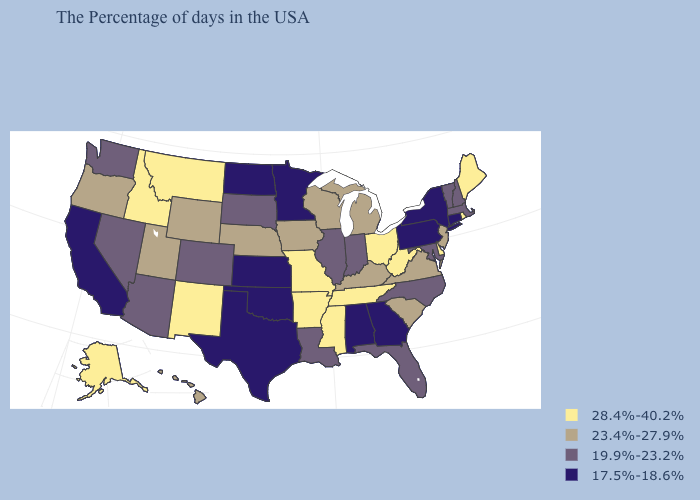Does the first symbol in the legend represent the smallest category?
Keep it brief. No. How many symbols are there in the legend?
Short answer required. 4. What is the value of Arkansas?
Quick response, please. 28.4%-40.2%. Does Oregon have the same value as Florida?
Quick response, please. No. Name the states that have a value in the range 28.4%-40.2%?
Write a very short answer. Maine, Rhode Island, Delaware, West Virginia, Ohio, Tennessee, Mississippi, Missouri, Arkansas, New Mexico, Montana, Idaho, Alaska. Name the states that have a value in the range 17.5%-18.6%?
Quick response, please. Connecticut, New York, Pennsylvania, Georgia, Alabama, Minnesota, Kansas, Oklahoma, Texas, North Dakota, California. What is the value of Nebraska?
Short answer required. 23.4%-27.9%. What is the value of Michigan?
Concise answer only. 23.4%-27.9%. Which states have the lowest value in the USA?
Give a very brief answer. Connecticut, New York, Pennsylvania, Georgia, Alabama, Minnesota, Kansas, Oklahoma, Texas, North Dakota, California. What is the highest value in states that border Texas?
Be succinct. 28.4%-40.2%. Among the states that border Louisiana , does Texas have the lowest value?
Quick response, please. Yes. Name the states that have a value in the range 23.4%-27.9%?
Keep it brief. New Jersey, Virginia, South Carolina, Michigan, Kentucky, Wisconsin, Iowa, Nebraska, Wyoming, Utah, Oregon, Hawaii. Does New Mexico have the highest value in the West?
Be succinct. Yes. What is the value of Connecticut?
Concise answer only. 17.5%-18.6%. 